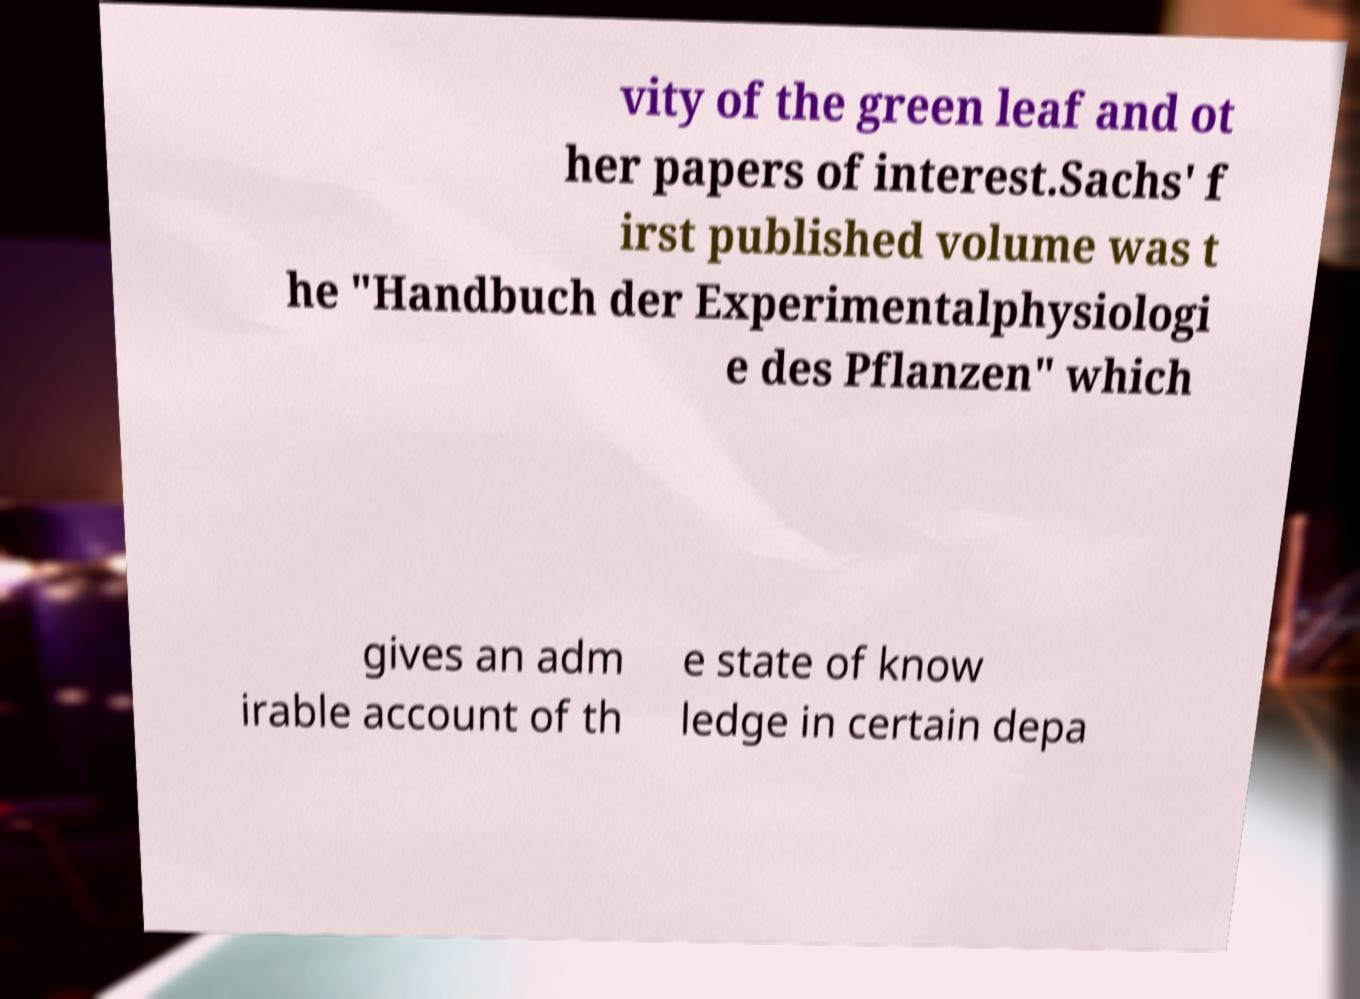Could you extract and type out the text from this image? vity of the green leaf and ot her papers of interest.Sachs' f irst published volume was t he "Handbuch der Experimentalphysiologi e des Pflanzen" which gives an adm irable account of th e state of know ledge in certain depa 